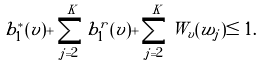Convert formula to latex. <formula><loc_0><loc_0><loc_500><loc_500>b _ { 1 } ^ { * } ( v ) + \sum _ { j = 2 } ^ { K } b _ { 1 } ^ { r } ( v ) + \sum _ { j = 2 } ^ { K } W _ { v } ( w _ { j } ) \leq 1 .</formula> 